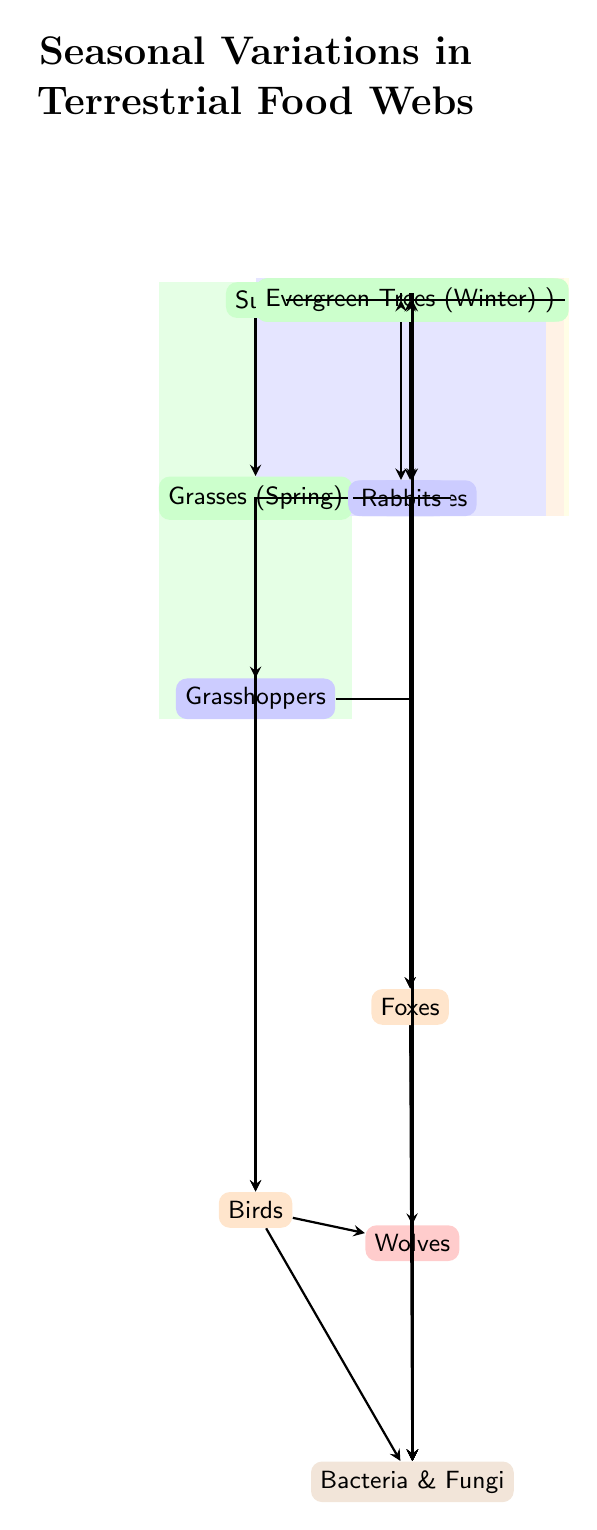What is the producer in Spring? In the Spring section of the diagram, the producer is represented by the node that produces energy, which is Grasses (Spring).
Answer: Grasses (Spring) How many herbivores are shown in the Summer? The Summer section contains one herbivore depicted as Butterflies. Since there is only one herbivore in this section, the answer is 1.
Answer: 1 Which carnivore is connected to herbivores in Spring? The herbivores in Spring include Grasshoppers, and the associated carnivore that consumes them is Birds. Therefore, Birds is the answer.
Answer: Birds How many total producers are represented in the diagram? The diagram has four seasonal groups: Spring, Summer, Autumn, and Winter, with each having one unique producer (Grasses, Flowering Plants, Deciduous Trees, and Evergreen Trees). Adding these gives a total of four producers.
Answer: 4 Which producer is linked to the carnivore that hunts in Winter? The carnivore in Winter is Foxes, which feed on Deer, the herbivore connected to the Deciduous Trees (Autumn). Hence, Deciduous Trees (Autumn) serves as the last producer for Foxes.
Answer: Deciduous Trees (Autumn) What is the role of Bacteria & Fungi in the food web? Bacteria & Fungi function as decomposers, breaking down organic material from various trophic levels within the food web, thus contributing to nutrient recycling.
Answer: Decomposer Which tertiary consumer is fed by the carnivores? The top carnivore in the diagram is Wolves, which is depicted as receiving energy from both Birds and Foxes, the primary carnivores of the food chain.
Answer: Wolves How many arrows originate from the Spring producer? In the Spring section, Grasses lead to two arrows, one connecting to Grasshoppers (herbivore) and one to Bacteria & Fungi (decomposer), indicating the energy flow.
Answer: 2 